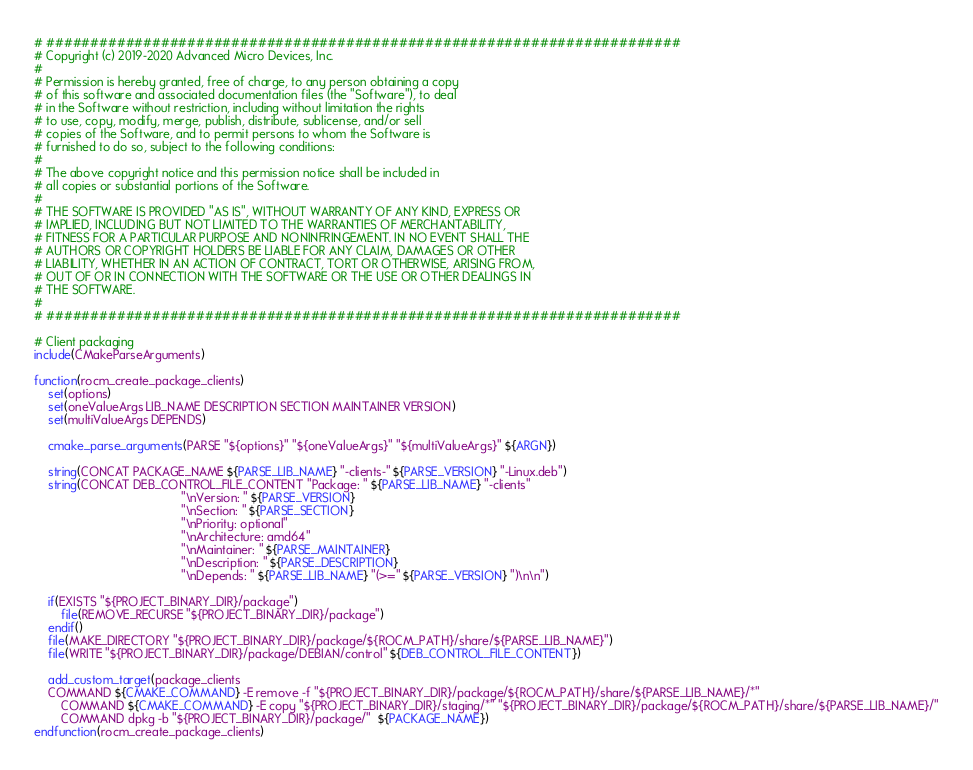Convert code to text. <code><loc_0><loc_0><loc_500><loc_500><_CMake_># ########################################################################
# Copyright (c) 2019-2020 Advanced Micro Devices, Inc.
#
# Permission is hereby granted, free of charge, to any person obtaining a copy
# of this software and associated documentation files (the "Software"), to deal
# in the Software without restriction, including without limitation the rights
# to use, copy, modify, merge, publish, distribute, sublicense, and/or sell
# copies of the Software, and to permit persons to whom the Software is
# furnished to do so, subject to the following conditions:
#
# The above copyright notice and this permission notice shall be included in
# all copies or substantial portions of the Software.
#
# THE SOFTWARE IS PROVIDED "AS IS", WITHOUT WARRANTY OF ANY KIND, EXPRESS OR
# IMPLIED, INCLUDING BUT NOT LIMITED TO THE WARRANTIES OF MERCHANTABILITY,
# FITNESS FOR A PARTICULAR PURPOSE AND NONINFRINGEMENT. IN NO EVENT SHALL THE
# AUTHORS OR COPYRIGHT HOLDERS BE LIABLE FOR ANY CLAIM, DAMAGES OR OTHER
# LIABILITY, WHETHER IN AN ACTION OF CONTRACT, TORT OR OTHERWISE, ARISING FROM,
# OUT OF OR IN CONNECTION WITH THE SOFTWARE OR THE USE OR OTHER DEALINGS IN
# THE SOFTWARE.
#
# ########################################################################

# Client packaging
include(CMakeParseArguments)

function(rocm_create_package_clients)
    set(options)
    set(oneValueArgs LIB_NAME DESCRIPTION SECTION MAINTAINER VERSION)
    set(multiValueArgs DEPENDS)

    cmake_parse_arguments(PARSE "${options}" "${oneValueArgs}" "${multiValueArgs}" ${ARGN})

    string(CONCAT PACKAGE_NAME ${PARSE_LIB_NAME} "-clients-" ${PARSE_VERSION} "-Linux.deb")
    string(CONCAT DEB_CONTROL_FILE_CONTENT "Package: " ${PARSE_LIB_NAME} "-clients"
                                           "\nVersion: " ${PARSE_VERSION}
                                           "\nSection: " ${PARSE_SECTION}
                                           "\nPriority: optional"
                                           "\nArchitecture: amd64"
                                           "\nMaintainer: " ${PARSE_MAINTAINER}
                                           "\nDescription: " ${PARSE_DESCRIPTION}
                                           "\nDepends: " ${PARSE_LIB_NAME} "(>=" ${PARSE_VERSION} ")\n\n")

    if(EXISTS "${PROJECT_BINARY_DIR}/package")
        file(REMOVE_RECURSE "${PROJECT_BINARY_DIR}/package")
    endif()
    file(MAKE_DIRECTORY "${PROJECT_BINARY_DIR}/package/${ROCM_PATH}/share/${PARSE_LIB_NAME}")
    file(WRITE "${PROJECT_BINARY_DIR}/package/DEBIAN/control" ${DEB_CONTROL_FILE_CONTENT})

    add_custom_target(package_clients
	COMMAND ${CMAKE_COMMAND} -E remove -f "${PROJECT_BINARY_DIR}/package/${ROCM_PATH}/share/${PARSE_LIB_NAME}/*"
        COMMAND ${CMAKE_COMMAND} -E copy "${PROJECT_BINARY_DIR}/staging/*" "${PROJECT_BINARY_DIR}/package/${ROCM_PATH}/share/${PARSE_LIB_NAME}/"
        COMMAND dpkg -b "${PROJECT_BINARY_DIR}/package/"  ${PACKAGE_NAME})
endfunction(rocm_create_package_clients)
</code> 